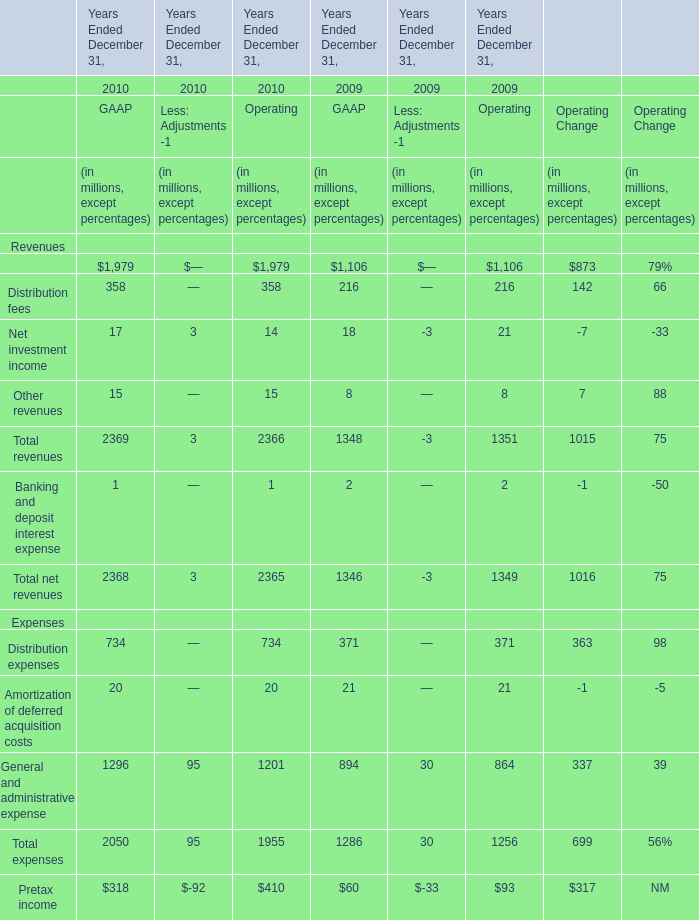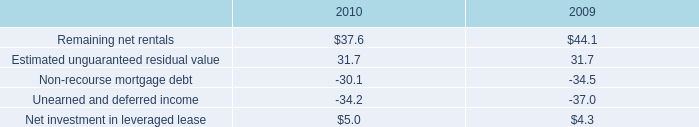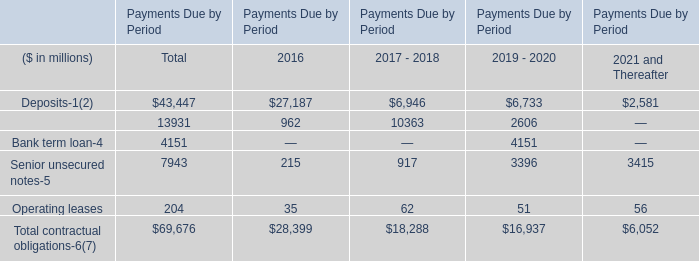what is the total sublease revenue , in millions , from 2008-2010? 
Computations: ((5.9 + 5.2) + 7.1)
Answer: 18.2. 